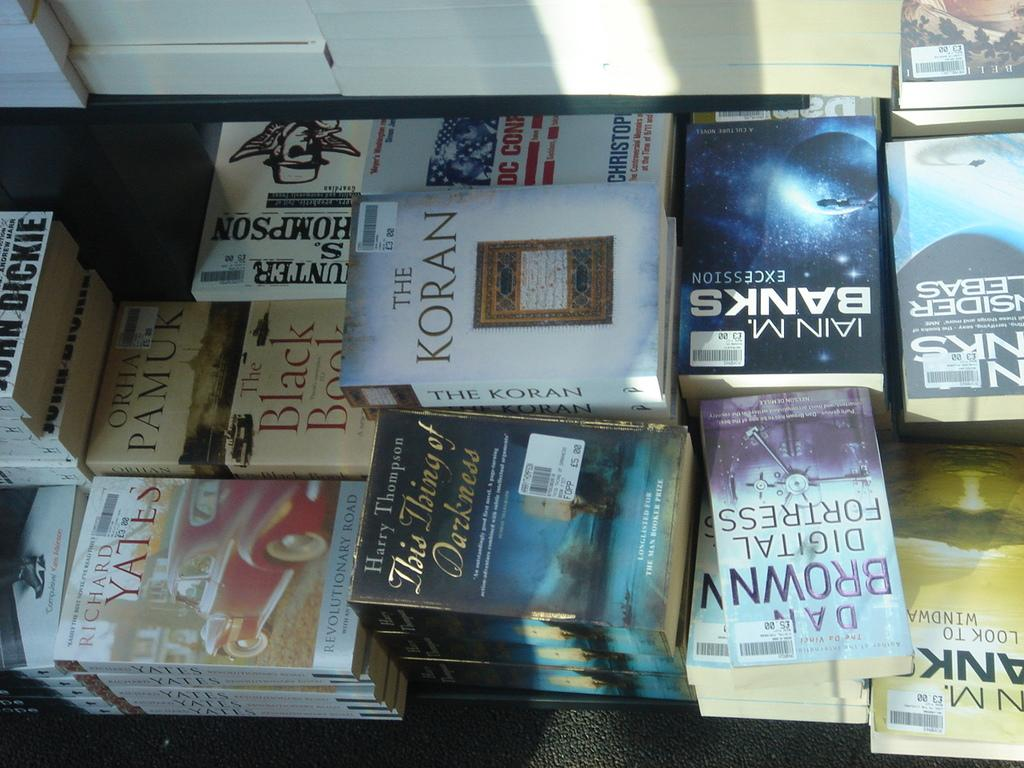<image>
Present a compact description of the photo's key features. A pile of books, the one in the middle says The Koran on it. 